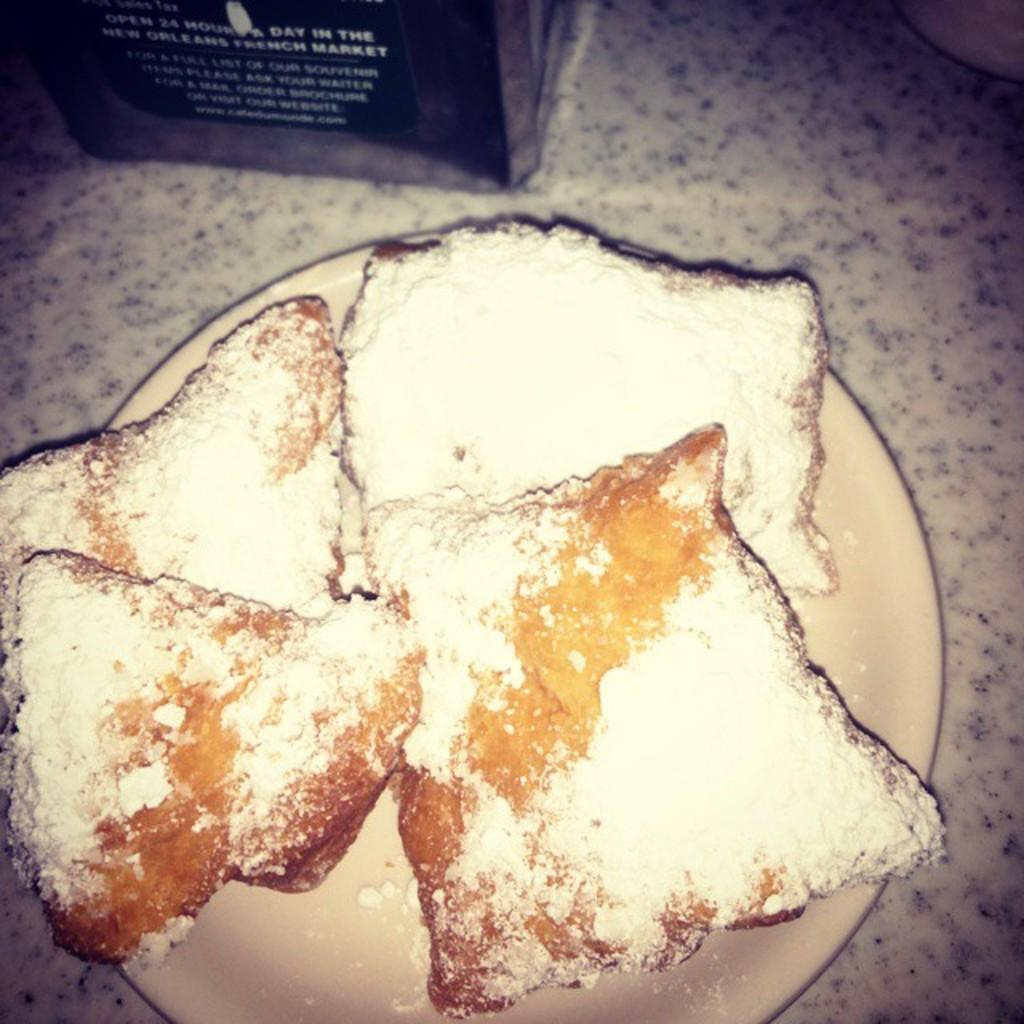What is located in the middle of the image? There is a plate with food items in the middle of the image. Where is the plate placed? The plate is on the floor. What can be seen at the top of the image? There are two objects at the top of the image. Are the objects on the floor as well? Yes, the objects are on the floor. What type of plants can be seen growing near the plate in the image? There are no plants visible in the image. 